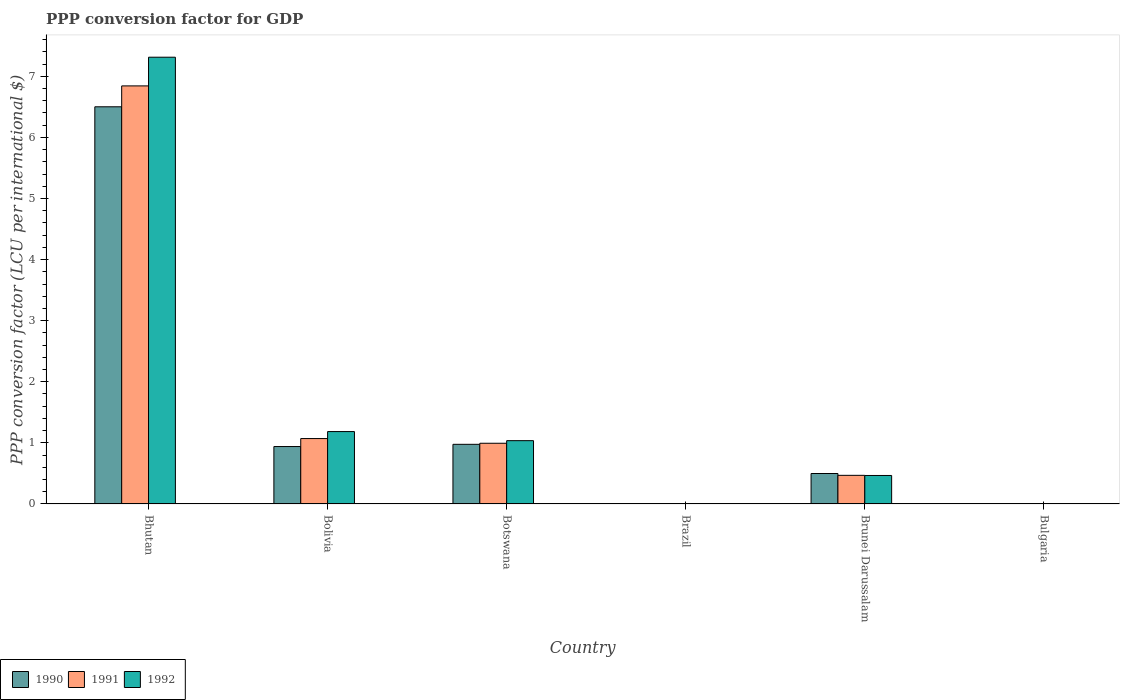How many bars are there on the 1st tick from the right?
Provide a succinct answer. 3. What is the label of the 5th group of bars from the left?
Ensure brevity in your answer.  Brunei Darussalam. In how many cases, is the number of bars for a given country not equal to the number of legend labels?
Make the answer very short. 0. What is the PPP conversion factor for GDP in 1992 in Brunei Darussalam?
Provide a short and direct response. 0.47. Across all countries, what is the maximum PPP conversion factor for GDP in 1992?
Offer a very short reply. 7.31. Across all countries, what is the minimum PPP conversion factor for GDP in 1990?
Provide a succinct answer. 1.1557525272828e-5. In which country was the PPP conversion factor for GDP in 1990 maximum?
Your answer should be very brief. Bhutan. In which country was the PPP conversion factor for GDP in 1990 minimum?
Provide a succinct answer. Brazil. What is the total PPP conversion factor for GDP in 1991 in the graph?
Your answer should be very brief. 9.38. What is the difference between the PPP conversion factor for GDP in 1992 in Bolivia and that in Brunei Darussalam?
Keep it short and to the point. 0.72. What is the difference between the PPP conversion factor for GDP in 1990 in Bolivia and the PPP conversion factor for GDP in 1992 in Brazil?
Provide a short and direct response. 0.94. What is the average PPP conversion factor for GDP in 1990 per country?
Provide a short and direct response. 1.49. What is the difference between the PPP conversion factor for GDP of/in 1991 and PPP conversion factor for GDP of/in 1990 in Bhutan?
Give a very brief answer. 0.34. In how many countries, is the PPP conversion factor for GDP in 1991 greater than 5.8 LCU?
Offer a terse response. 1. What is the ratio of the PPP conversion factor for GDP in 1990 in Brazil to that in Brunei Darussalam?
Ensure brevity in your answer.  2.3182840573090485e-5. Is the difference between the PPP conversion factor for GDP in 1991 in Bhutan and Bulgaria greater than the difference between the PPP conversion factor for GDP in 1990 in Bhutan and Bulgaria?
Make the answer very short. Yes. What is the difference between the highest and the second highest PPP conversion factor for GDP in 1991?
Offer a terse response. -0.08. What is the difference between the highest and the lowest PPP conversion factor for GDP in 1991?
Your answer should be compact. 6.84. In how many countries, is the PPP conversion factor for GDP in 1990 greater than the average PPP conversion factor for GDP in 1990 taken over all countries?
Make the answer very short. 1. Is the sum of the PPP conversion factor for GDP in 1990 in Bolivia and Bulgaria greater than the maximum PPP conversion factor for GDP in 1991 across all countries?
Offer a terse response. No. How many bars are there?
Make the answer very short. 18. Are all the bars in the graph horizontal?
Offer a terse response. No. Are the values on the major ticks of Y-axis written in scientific E-notation?
Provide a succinct answer. No. Does the graph contain any zero values?
Keep it short and to the point. No. Where does the legend appear in the graph?
Make the answer very short. Bottom left. What is the title of the graph?
Your answer should be compact. PPP conversion factor for GDP. Does "2011" appear as one of the legend labels in the graph?
Provide a succinct answer. No. What is the label or title of the X-axis?
Offer a terse response. Country. What is the label or title of the Y-axis?
Provide a succinct answer. PPP conversion factor (LCU per international $). What is the PPP conversion factor (LCU per international $) of 1990 in Bhutan?
Your answer should be very brief. 6.5. What is the PPP conversion factor (LCU per international $) of 1991 in Bhutan?
Offer a terse response. 6.84. What is the PPP conversion factor (LCU per international $) in 1992 in Bhutan?
Provide a succinct answer. 7.31. What is the PPP conversion factor (LCU per international $) in 1990 in Bolivia?
Offer a terse response. 0.94. What is the PPP conversion factor (LCU per international $) in 1991 in Bolivia?
Offer a very short reply. 1.07. What is the PPP conversion factor (LCU per international $) of 1992 in Bolivia?
Provide a short and direct response. 1.18. What is the PPP conversion factor (LCU per international $) of 1990 in Botswana?
Ensure brevity in your answer.  0.98. What is the PPP conversion factor (LCU per international $) in 1991 in Botswana?
Keep it short and to the point. 0.99. What is the PPP conversion factor (LCU per international $) in 1992 in Botswana?
Give a very brief answer. 1.04. What is the PPP conversion factor (LCU per international $) in 1990 in Brazil?
Keep it short and to the point. 1.1557525272828e-5. What is the PPP conversion factor (LCU per international $) of 1991 in Brazil?
Your answer should be compact. 5.75184759112572e-5. What is the PPP conversion factor (LCU per international $) of 1992 in Brazil?
Make the answer very short. 0. What is the PPP conversion factor (LCU per international $) in 1990 in Brunei Darussalam?
Make the answer very short. 0.5. What is the PPP conversion factor (LCU per international $) in 1991 in Brunei Darussalam?
Give a very brief answer. 0.47. What is the PPP conversion factor (LCU per international $) in 1992 in Brunei Darussalam?
Make the answer very short. 0.47. What is the PPP conversion factor (LCU per international $) of 1990 in Bulgaria?
Give a very brief answer. 0. What is the PPP conversion factor (LCU per international $) in 1991 in Bulgaria?
Provide a short and direct response. 0. What is the PPP conversion factor (LCU per international $) of 1992 in Bulgaria?
Your answer should be very brief. 0. Across all countries, what is the maximum PPP conversion factor (LCU per international $) of 1990?
Your answer should be compact. 6.5. Across all countries, what is the maximum PPP conversion factor (LCU per international $) of 1991?
Make the answer very short. 6.84. Across all countries, what is the maximum PPP conversion factor (LCU per international $) of 1992?
Provide a succinct answer. 7.31. Across all countries, what is the minimum PPP conversion factor (LCU per international $) of 1990?
Your answer should be compact. 1.1557525272828e-5. Across all countries, what is the minimum PPP conversion factor (LCU per international $) in 1991?
Provide a short and direct response. 5.75184759112572e-5. Across all countries, what is the minimum PPP conversion factor (LCU per international $) in 1992?
Provide a short and direct response. 0. What is the total PPP conversion factor (LCU per international $) of 1990 in the graph?
Ensure brevity in your answer.  8.92. What is the total PPP conversion factor (LCU per international $) in 1991 in the graph?
Ensure brevity in your answer.  9.38. What is the total PPP conversion factor (LCU per international $) of 1992 in the graph?
Keep it short and to the point. 10.01. What is the difference between the PPP conversion factor (LCU per international $) in 1990 in Bhutan and that in Bolivia?
Offer a very short reply. 5.56. What is the difference between the PPP conversion factor (LCU per international $) in 1991 in Bhutan and that in Bolivia?
Provide a succinct answer. 5.77. What is the difference between the PPP conversion factor (LCU per international $) of 1992 in Bhutan and that in Bolivia?
Your answer should be compact. 6.13. What is the difference between the PPP conversion factor (LCU per international $) of 1990 in Bhutan and that in Botswana?
Your response must be concise. 5.52. What is the difference between the PPP conversion factor (LCU per international $) of 1991 in Bhutan and that in Botswana?
Give a very brief answer. 5.85. What is the difference between the PPP conversion factor (LCU per international $) in 1992 in Bhutan and that in Botswana?
Give a very brief answer. 6.28. What is the difference between the PPP conversion factor (LCU per international $) of 1990 in Bhutan and that in Brazil?
Give a very brief answer. 6.5. What is the difference between the PPP conversion factor (LCU per international $) in 1991 in Bhutan and that in Brazil?
Your answer should be very brief. 6.84. What is the difference between the PPP conversion factor (LCU per international $) in 1992 in Bhutan and that in Brazil?
Offer a terse response. 7.31. What is the difference between the PPP conversion factor (LCU per international $) of 1990 in Bhutan and that in Brunei Darussalam?
Provide a succinct answer. 6. What is the difference between the PPP conversion factor (LCU per international $) in 1991 in Bhutan and that in Brunei Darussalam?
Your answer should be very brief. 6.37. What is the difference between the PPP conversion factor (LCU per international $) of 1992 in Bhutan and that in Brunei Darussalam?
Offer a very short reply. 6.85. What is the difference between the PPP conversion factor (LCU per international $) in 1990 in Bhutan and that in Bulgaria?
Your answer should be compact. 6.5. What is the difference between the PPP conversion factor (LCU per international $) in 1991 in Bhutan and that in Bulgaria?
Provide a succinct answer. 6.84. What is the difference between the PPP conversion factor (LCU per international $) of 1992 in Bhutan and that in Bulgaria?
Your response must be concise. 7.31. What is the difference between the PPP conversion factor (LCU per international $) in 1990 in Bolivia and that in Botswana?
Give a very brief answer. -0.04. What is the difference between the PPP conversion factor (LCU per international $) in 1991 in Bolivia and that in Botswana?
Your answer should be compact. 0.08. What is the difference between the PPP conversion factor (LCU per international $) in 1992 in Bolivia and that in Botswana?
Provide a short and direct response. 0.15. What is the difference between the PPP conversion factor (LCU per international $) of 1991 in Bolivia and that in Brazil?
Ensure brevity in your answer.  1.07. What is the difference between the PPP conversion factor (LCU per international $) in 1992 in Bolivia and that in Brazil?
Offer a terse response. 1.18. What is the difference between the PPP conversion factor (LCU per international $) in 1990 in Bolivia and that in Brunei Darussalam?
Your answer should be compact. 0.44. What is the difference between the PPP conversion factor (LCU per international $) in 1991 in Bolivia and that in Brunei Darussalam?
Your response must be concise. 0.6. What is the difference between the PPP conversion factor (LCU per international $) of 1992 in Bolivia and that in Brunei Darussalam?
Offer a terse response. 0.72. What is the difference between the PPP conversion factor (LCU per international $) in 1990 in Bolivia and that in Bulgaria?
Keep it short and to the point. 0.94. What is the difference between the PPP conversion factor (LCU per international $) of 1991 in Bolivia and that in Bulgaria?
Provide a short and direct response. 1.07. What is the difference between the PPP conversion factor (LCU per international $) in 1992 in Bolivia and that in Bulgaria?
Provide a succinct answer. 1.18. What is the difference between the PPP conversion factor (LCU per international $) of 1990 in Botswana and that in Brazil?
Ensure brevity in your answer.  0.98. What is the difference between the PPP conversion factor (LCU per international $) of 1992 in Botswana and that in Brazil?
Provide a succinct answer. 1.04. What is the difference between the PPP conversion factor (LCU per international $) of 1990 in Botswana and that in Brunei Darussalam?
Your answer should be compact. 0.48. What is the difference between the PPP conversion factor (LCU per international $) of 1991 in Botswana and that in Brunei Darussalam?
Provide a succinct answer. 0.53. What is the difference between the PPP conversion factor (LCU per international $) of 1992 in Botswana and that in Brunei Darussalam?
Your answer should be very brief. 0.57. What is the difference between the PPP conversion factor (LCU per international $) in 1990 in Botswana and that in Bulgaria?
Give a very brief answer. 0.98. What is the difference between the PPP conversion factor (LCU per international $) of 1992 in Botswana and that in Bulgaria?
Provide a succinct answer. 1.03. What is the difference between the PPP conversion factor (LCU per international $) in 1990 in Brazil and that in Brunei Darussalam?
Provide a succinct answer. -0.5. What is the difference between the PPP conversion factor (LCU per international $) in 1991 in Brazil and that in Brunei Darussalam?
Keep it short and to the point. -0.47. What is the difference between the PPP conversion factor (LCU per international $) in 1992 in Brazil and that in Brunei Darussalam?
Make the answer very short. -0.47. What is the difference between the PPP conversion factor (LCU per international $) in 1990 in Brazil and that in Bulgaria?
Keep it short and to the point. -0. What is the difference between the PPP conversion factor (LCU per international $) in 1991 in Brazil and that in Bulgaria?
Your response must be concise. -0. What is the difference between the PPP conversion factor (LCU per international $) in 1992 in Brazil and that in Bulgaria?
Give a very brief answer. -0. What is the difference between the PPP conversion factor (LCU per international $) in 1990 in Brunei Darussalam and that in Bulgaria?
Your response must be concise. 0.5. What is the difference between the PPP conversion factor (LCU per international $) in 1991 in Brunei Darussalam and that in Bulgaria?
Your answer should be very brief. 0.47. What is the difference between the PPP conversion factor (LCU per international $) in 1992 in Brunei Darussalam and that in Bulgaria?
Provide a short and direct response. 0.46. What is the difference between the PPP conversion factor (LCU per international $) of 1990 in Bhutan and the PPP conversion factor (LCU per international $) of 1991 in Bolivia?
Give a very brief answer. 5.43. What is the difference between the PPP conversion factor (LCU per international $) in 1990 in Bhutan and the PPP conversion factor (LCU per international $) in 1992 in Bolivia?
Your answer should be compact. 5.32. What is the difference between the PPP conversion factor (LCU per international $) of 1991 in Bhutan and the PPP conversion factor (LCU per international $) of 1992 in Bolivia?
Give a very brief answer. 5.66. What is the difference between the PPP conversion factor (LCU per international $) in 1990 in Bhutan and the PPP conversion factor (LCU per international $) in 1991 in Botswana?
Offer a very short reply. 5.51. What is the difference between the PPP conversion factor (LCU per international $) in 1990 in Bhutan and the PPP conversion factor (LCU per international $) in 1992 in Botswana?
Offer a very short reply. 5.46. What is the difference between the PPP conversion factor (LCU per international $) of 1991 in Bhutan and the PPP conversion factor (LCU per international $) of 1992 in Botswana?
Your response must be concise. 5.81. What is the difference between the PPP conversion factor (LCU per international $) of 1990 in Bhutan and the PPP conversion factor (LCU per international $) of 1991 in Brazil?
Keep it short and to the point. 6.5. What is the difference between the PPP conversion factor (LCU per international $) of 1990 in Bhutan and the PPP conversion factor (LCU per international $) of 1992 in Brazil?
Your answer should be compact. 6.5. What is the difference between the PPP conversion factor (LCU per international $) in 1991 in Bhutan and the PPP conversion factor (LCU per international $) in 1992 in Brazil?
Your response must be concise. 6.84. What is the difference between the PPP conversion factor (LCU per international $) in 1990 in Bhutan and the PPP conversion factor (LCU per international $) in 1991 in Brunei Darussalam?
Keep it short and to the point. 6.03. What is the difference between the PPP conversion factor (LCU per international $) in 1990 in Bhutan and the PPP conversion factor (LCU per international $) in 1992 in Brunei Darussalam?
Make the answer very short. 6.03. What is the difference between the PPP conversion factor (LCU per international $) in 1991 in Bhutan and the PPP conversion factor (LCU per international $) in 1992 in Brunei Darussalam?
Ensure brevity in your answer.  6.38. What is the difference between the PPP conversion factor (LCU per international $) of 1990 in Bhutan and the PPP conversion factor (LCU per international $) of 1991 in Bulgaria?
Keep it short and to the point. 6.5. What is the difference between the PPP conversion factor (LCU per international $) in 1990 in Bhutan and the PPP conversion factor (LCU per international $) in 1992 in Bulgaria?
Ensure brevity in your answer.  6.5. What is the difference between the PPP conversion factor (LCU per international $) in 1991 in Bhutan and the PPP conversion factor (LCU per international $) in 1992 in Bulgaria?
Give a very brief answer. 6.84. What is the difference between the PPP conversion factor (LCU per international $) in 1990 in Bolivia and the PPP conversion factor (LCU per international $) in 1991 in Botswana?
Your answer should be compact. -0.05. What is the difference between the PPP conversion factor (LCU per international $) of 1990 in Bolivia and the PPP conversion factor (LCU per international $) of 1992 in Botswana?
Keep it short and to the point. -0.1. What is the difference between the PPP conversion factor (LCU per international $) in 1991 in Bolivia and the PPP conversion factor (LCU per international $) in 1992 in Botswana?
Keep it short and to the point. 0.03. What is the difference between the PPP conversion factor (LCU per international $) in 1990 in Bolivia and the PPP conversion factor (LCU per international $) in 1991 in Brazil?
Keep it short and to the point. 0.94. What is the difference between the PPP conversion factor (LCU per international $) of 1990 in Bolivia and the PPP conversion factor (LCU per international $) of 1992 in Brazil?
Your answer should be compact. 0.94. What is the difference between the PPP conversion factor (LCU per international $) of 1991 in Bolivia and the PPP conversion factor (LCU per international $) of 1992 in Brazil?
Make the answer very short. 1.07. What is the difference between the PPP conversion factor (LCU per international $) in 1990 in Bolivia and the PPP conversion factor (LCU per international $) in 1991 in Brunei Darussalam?
Provide a succinct answer. 0.47. What is the difference between the PPP conversion factor (LCU per international $) of 1990 in Bolivia and the PPP conversion factor (LCU per international $) of 1992 in Brunei Darussalam?
Provide a short and direct response. 0.47. What is the difference between the PPP conversion factor (LCU per international $) in 1991 in Bolivia and the PPP conversion factor (LCU per international $) in 1992 in Brunei Darussalam?
Provide a succinct answer. 0.6. What is the difference between the PPP conversion factor (LCU per international $) in 1990 in Bolivia and the PPP conversion factor (LCU per international $) in 1991 in Bulgaria?
Your answer should be compact. 0.94. What is the difference between the PPP conversion factor (LCU per international $) in 1990 in Bolivia and the PPP conversion factor (LCU per international $) in 1992 in Bulgaria?
Keep it short and to the point. 0.94. What is the difference between the PPP conversion factor (LCU per international $) of 1991 in Bolivia and the PPP conversion factor (LCU per international $) of 1992 in Bulgaria?
Ensure brevity in your answer.  1.07. What is the difference between the PPP conversion factor (LCU per international $) in 1990 in Botswana and the PPP conversion factor (LCU per international $) in 1991 in Brazil?
Your response must be concise. 0.98. What is the difference between the PPP conversion factor (LCU per international $) of 1990 in Botswana and the PPP conversion factor (LCU per international $) of 1992 in Brazil?
Your answer should be compact. 0.98. What is the difference between the PPP conversion factor (LCU per international $) of 1991 in Botswana and the PPP conversion factor (LCU per international $) of 1992 in Brazil?
Ensure brevity in your answer.  0.99. What is the difference between the PPP conversion factor (LCU per international $) of 1990 in Botswana and the PPP conversion factor (LCU per international $) of 1991 in Brunei Darussalam?
Your answer should be compact. 0.51. What is the difference between the PPP conversion factor (LCU per international $) of 1990 in Botswana and the PPP conversion factor (LCU per international $) of 1992 in Brunei Darussalam?
Give a very brief answer. 0.51. What is the difference between the PPP conversion factor (LCU per international $) of 1991 in Botswana and the PPP conversion factor (LCU per international $) of 1992 in Brunei Darussalam?
Keep it short and to the point. 0.53. What is the difference between the PPP conversion factor (LCU per international $) in 1990 in Botswana and the PPP conversion factor (LCU per international $) in 1991 in Bulgaria?
Give a very brief answer. 0.97. What is the difference between the PPP conversion factor (LCU per international $) in 1990 in Botswana and the PPP conversion factor (LCU per international $) in 1992 in Bulgaria?
Give a very brief answer. 0.97. What is the difference between the PPP conversion factor (LCU per international $) of 1990 in Brazil and the PPP conversion factor (LCU per international $) of 1991 in Brunei Darussalam?
Your answer should be compact. -0.47. What is the difference between the PPP conversion factor (LCU per international $) of 1990 in Brazil and the PPP conversion factor (LCU per international $) of 1992 in Brunei Darussalam?
Make the answer very short. -0.47. What is the difference between the PPP conversion factor (LCU per international $) of 1991 in Brazil and the PPP conversion factor (LCU per international $) of 1992 in Brunei Darussalam?
Your response must be concise. -0.47. What is the difference between the PPP conversion factor (LCU per international $) in 1990 in Brazil and the PPP conversion factor (LCU per international $) in 1991 in Bulgaria?
Give a very brief answer. -0. What is the difference between the PPP conversion factor (LCU per international $) in 1990 in Brazil and the PPP conversion factor (LCU per international $) in 1992 in Bulgaria?
Provide a succinct answer. -0. What is the difference between the PPP conversion factor (LCU per international $) of 1991 in Brazil and the PPP conversion factor (LCU per international $) of 1992 in Bulgaria?
Keep it short and to the point. -0. What is the difference between the PPP conversion factor (LCU per international $) in 1990 in Brunei Darussalam and the PPP conversion factor (LCU per international $) in 1991 in Bulgaria?
Make the answer very short. 0.5. What is the difference between the PPP conversion factor (LCU per international $) in 1990 in Brunei Darussalam and the PPP conversion factor (LCU per international $) in 1992 in Bulgaria?
Your answer should be compact. 0.49. What is the difference between the PPP conversion factor (LCU per international $) in 1991 in Brunei Darussalam and the PPP conversion factor (LCU per international $) in 1992 in Bulgaria?
Offer a terse response. 0.46. What is the average PPP conversion factor (LCU per international $) of 1990 per country?
Keep it short and to the point. 1.49. What is the average PPP conversion factor (LCU per international $) of 1991 per country?
Provide a short and direct response. 1.56. What is the average PPP conversion factor (LCU per international $) in 1992 per country?
Provide a succinct answer. 1.67. What is the difference between the PPP conversion factor (LCU per international $) in 1990 and PPP conversion factor (LCU per international $) in 1991 in Bhutan?
Provide a succinct answer. -0.34. What is the difference between the PPP conversion factor (LCU per international $) in 1990 and PPP conversion factor (LCU per international $) in 1992 in Bhutan?
Offer a terse response. -0.81. What is the difference between the PPP conversion factor (LCU per international $) of 1991 and PPP conversion factor (LCU per international $) of 1992 in Bhutan?
Provide a succinct answer. -0.47. What is the difference between the PPP conversion factor (LCU per international $) of 1990 and PPP conversion factor (LCU per international $) of 1991 in Bolivia?
Your answer should be very brief. -0.13. What is the difference between the PPP conversion factor (LCU per international $) in 1990 and PPP conversion factor (LCU per international $) in 1992 in Bolivia?
Ensure brevity in your answer.  -0.24. What is the difference between the PPP conversion factor (LCU per international $) of 1991 and PPP conversion factor (LCU per international $) of 1992 in Bolivia?
Offer a terse response. -0.11. What is the difference between the PPP conversion factor (LCU per international $) in 1990 and PPP conversion factor (LCU per international $) in 1991 in Botswana?
Ensure brevity in your answer.  -0.02. What is the difference between the PPP conversion factor (LCU per international $) in 1990 and PPP conversion factor (LCU per international $) in 1992 in Botswana?
Your response must be concise. -0.06. What is the difference between the PPP conversion factor (LCU per international $) of 1991 and PPP conversion factor (LCU per international $) of 1992 in Botswana?
Your answer should be very brief. -0.04. What is the difference between the PPP conversion factor (LCU per international $) in 1990 and PPP conversion factor (LCU per international $) in 1991 in Brazil?
Your response must be concise. -0. What is the difference between the PPP conversion factor (LCU per international $) of 1990 and PPP conversion factor (LCU per international $) of 1992 in Brazil?
Provide a short and direct response. -0. What is the difference between the PPP conversion factor (LCU per international $) in 1991 and PPP conversion factor (LCU per international $) in 1992 in Brazil?
Provide a short and direct response. -0. What is the difference between the PPP conversion factor (LCU per international $) of 1990 and PPP conversion factor (LCU per international $) of 1991 in Brunei Darussalam?
Your answer should be compact. 0.03. What is the difference between the PPP conversion factor (LCU per international $) in 1990 and PPP conversion factor (LCU per international $) in 1992 in Brunei Darussalam?
Give a very brief answer. 0.03. What is the difference between the PPP conversion factor (LCU per international $) in 1991 and PPP conversion factor (LCU per international $) in 1992 in Brunei Darussalam?
Make the answer very short. 0. What is the difference between the PPP conversion factor (LCU per international $) in 1990 and PPP conversion factor (LCU per international $) in 1991 in Bulgaria?
Offer a terse response. -0. What is the difference between the PPP conversion factor (LCU per international $) of 1990 and PPP conversion factor (LCU per international $) of 1992 in Bulgaria?
Provide a short and direct response. -0. What is the difference between the PPP conversion factor (LCU per international $) of 1991 and PPP conversion factor (LCU per international $) of 1992 in Bulgaria?
Your answer should be compact. -0. What is the ratio of the PPP conversion factor (LCU per international $) of 1990 in Bhutan to that in Bolivia?
Give a very brief answer. 6.92. What is the ratio of the PPP conversion factor (LCU per international $) in 1991 in Bhutan to that in Bolivia?
Provide a succinct answer. 6.39. What is the ratio of the PPP conversion factor (LCU per international $) of 1992 in Bhutan to that in Bolivia?
Your response must be concise. 6.17. What is the ratio of the PPP conversion factor (LCU per international $) in 1990 in Bhutan to that in Botswana?
Give a very brief answer. 6.66. What is the ratio of the PPP conversion factor (LCU per international $) of 1991 in Bhutan to that in Botswana?
Keep it short and to the point. 6.89. What is the ratio of the PPP conversion factor (LCU per international $) in 1992 in Bhutan to that in Botswana?
Ensure brevity in your answer.  7.06. What is the ratio of the PPP conversion factor (LCU per international $) in 1990 in Bhutan to that in Brazil?
Your answer should be very brief. 5.62e+05. What is the ratio of the PPP conversion factor (LCU per international $) in 1991 in Bhutan to that in Brazil?
Make the answer very short. 1.19e+05. What is the ratio of the PPP conversion factor (LCU per international $) of 1992 in Bhutan to that in Brazil?
Your answer should be compact. 1.22e+04. What is the ratio of the PPP conversion factor (LCU per international $) of 1990 in Bhutan to that in Brunei Darussalam?
Offer a terse response. 13.04. What is the ratio of the PPP conversion factor (LCU per international $) of 1991 in Bhutan to that in Brunei Darussalam?
Ensure brevity in your answer.  14.6. What is the ratio of the PPP conversion factor (LCU per international $) in 1992 in Bhutan to that in Brunei Darussalam?
Offer a very short reply. 15.68. What is the ratio of the PPP conversion factor (LCU per international $) in 1990 in Bhutan to that in Bulgaria?
Provide a short and direct response. 6753.92. What is the ratio of the PPP conversion factor (LCU per international $) of 1991 in Bhutan to that in Bulgaria?
Make the answer very short. 2249.62. What is the ratio of the PPP conversion factor (LCU per international $) of 1992 in Bhutan to that in Bulgaria?
Offer a terse response. 1540.78. What is the ratio of the PPP conversion factor (LCU per international $) of 1990 in Bolivia to that in Botswana?
Offer a terse response. 0.96. What is the ratio of the PPP conversion factor (LCU per international $) in 1991 in Bolivia to that in Botswana?
Keep it short and to the point. 1.08. What is the ratio of the PPP conversion factor (LCU per international $) in 1992 in Bolivia to that in Botswana?
Keep it short and to the point. 1.14. What is the ratio of the PPP conversion factor (LCU per international $) in 1990 in Bolivia to that in Brazil?
Make the answer very short. 8.13e+04. What is the ratio of the PPP conversion factor (LCU per international $) in 1991 in Bolivia to that in Brazil?
Keep it short and to the point. 1.86e+04. What is the ratio of the PPP conversion factor (LCU per international $) in 1992 in Bolivia to that in Brazil?
Provide a short and direct response. 1972.64. What is the ratio of the PPP conversion factor (LCU per international $) in 1990 in Bolivia to that in Brunei Darussalam?
Make the answer very short. 1.89. What is the ratio of the PPP conversion factor (LCU per international $) of 1991 in Bolivia to that in Brunei Darussalam?
Your response must be concise. 2.28. What is the ratio of the PPP conversion factor (LCU per international $) in 1992 in Bolivia to that in Brunei Darussalam?
Offer a very short reply. 2.54. What is the ratio of the PPP conversion factor (LCU per international $) in 1990 in Bolivia to that in Bulgaria?
Provide a short and direct response. 976.62. What is the ratio of the PPP conversion factor (LCU per international $) in 1991 in Bolivia to that in Bulgaria?
Make the answer very short. 351.99. What is the ratio of the PPP conversion factor (LCU per international $) in 1992 in Bolivia to that in Bulgaria?
Your answer should be very brief. 249.69. What is the ratio of the PPP conversion factor (LCU per international $) of 1990 in Botswana to that in Brazil?
Keep it short and to the point. 8.45e+04. What is the ratio of the PPP conversion factor (LCU per international $) of 1991 in Botswana to that in Brazil?
Provide a short and direct response. 1.73e+04. What is the ratio of the PPP conversion factor (LCU per international $) of 1992 in Botswana to that in Brazil?
Make the answer very short. 1724.96. What is the ratio of the PPP conversion factor (LCU per international $) of 1990 in Botswana to that in Brunei Darussalam?
Ensure brevity in your answer.  1.96. What is the ratio of the PPP conversion factor (LCU per international $) of 1991 in Botswana to that in Brunei Darussalam?
Provide a succinct answer. 2.12. What is the ratio of the PPP conversion factor (LCU per international $) in 1992 in Botswana to that in Brunei Darussalam?
Make the answer very short. 2.22. What is the ratio of the PPP conversion factor (LCU per international $) in 1990 in Botswana to that in Bulgaria?
Your answer should be compact. 1014.36. What is the ratio of the PPP conversion factor (LCU per international $) in 1991 in Botswana to that in Bulgaria?
Ensure brevity in your answer.  326.73. What is the ratio of the PPP conversion factor (LCU per international $) of 1992 in Botswana to that in Bulgaria?
Provide a succinct answer. 218.34. What is the ratio of the PPP conversion factor (LCU per international $) in 1991 in Brazil to that in Brunei Darussalam?
Give a very brief answer. 0. What is the ratio of the PPP conversion factor (LCU per international $) in 1992 in Brazil to that in Brunei Darussalam?
Offer a terse response. 0. What is the ratio of the PPP conversion factor (LCU per international $) of 1990 in Brazil to that in Bulgaria?
Give a very brief answer. 0.01. What is the ratio of the PPP conversion factor (LCU per international $) of 1991 in Brazil to that in Bulgaria?
Offer a terse response. 0.02. What is the ratio of the PPP conversion factor (LCU per international $) of 1992 in Brazil to that in Bulgaria?
Provide a short and direct response. 0.13. What is the ratio of the PPP conversion factor (LCU per international $) in 1990 in Brunei Darussalam to that in Bulgaria?
Your answer should be compact. 517.94. What is the ratio of the PPP conversion factor (LCU per international $) of 1991 in Brunei Darussalam to that in Bulgaria?
Provide a short and direct response. 154.12. What is the ratio of the PPP conversion factor (LCU per international $) of 1992 in Brunei Darussalam to that in Bulgaria?
Your answer should be compact. 98.24. What is the difference between the highest and the second highest PPP conversion factor (LCU per international $) in 1990?
Your answer should be very brief. 5.52. What is the difference between the highest and the second highest PPP conversion factor (LCU per international $) in 1991?
Make the answer very short. 5.77. What is the difference between the highest and the second highest PPP conversion factor (LCU per international $) in 1992?
Offer a very short reply. 6.13. What is the difference between the highest and the lowest PPP conversion factor (LCU per international $) in 1990?
Make the answer very short. 6.5. What is the difference between the highest and the lowest PPP conversion factor (LCU per international $) in 1991?
Ensure brevity in your answer.  6.84. What is the difference between the highest and the lowest PPP conversion factor (LCU per international $) of 1992?
Provide a succinct answer. 7.31. 